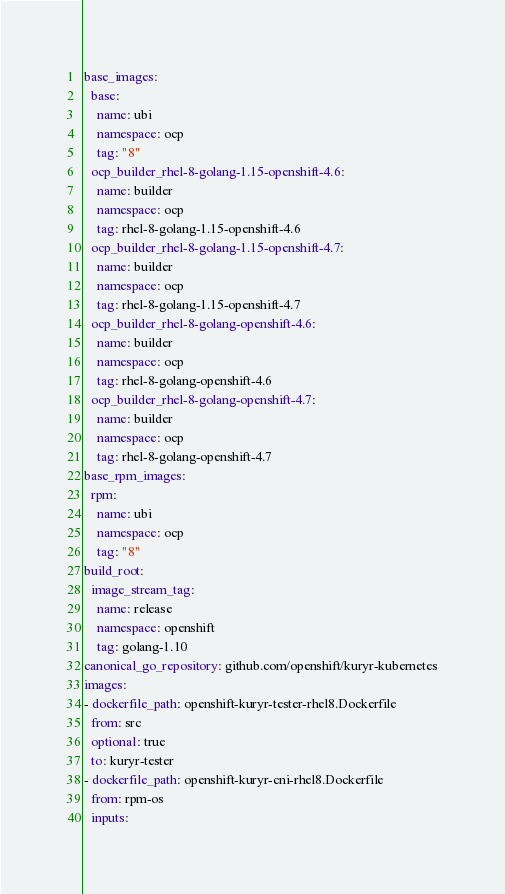<code> <loc_0><loc_0><loc_500><loc_500><_YAML_>base_images:
  base:
    name: ubi
    namespace: ocp
    tag: "8"
  ocp_builder_rhel-8-golang-1.15-openshift-4.6:
    name: builder
    namespace: ocp
    tag: rhel-8-golang-1.15-openshift-4.6
  ocp_builder_rhel-8-golang-1.15-openshift-4.7:
    name: builder
    namespace: ocp
    tag: rhel-8-golang-1.15-openshift-4.7
  ocp_builder_rhel-8-golang-openshift-4.6:
    name: builder
    namespace: ocp
    tag: rhel-8-golang-openshift-4.6
  ocp_builder_rhel-8-golang-openshift-4.7:
    name: builder
    namespace: ocp
    tag: rhel-8-golang-openshift-4.7
base_rpm_images:
  rpm:
    name: ubi
    namespace: ocp
    tag: "8"
build_root:
  image_stream_tag:
    name: release
    namespace: openshift
    tag: golang-1.10
canonical_go_repository: github.com/openshift/kuryr-kubernetes
images:
- dockerfile_path: openshift-kuryr-tester-rhel8.Dockerfile
  from: src
  optional: true
  to: kuryr-tester
- dockerfile_path: openshift-kuryr-cni-rhel8.Dockerfile
  from: rpm-os
  inputs:</code> 